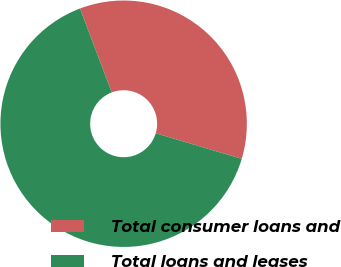Convert chart. <chart><loc_0><loc_0><loc_500><loc_500><pie_chart><fcel>Total consumer loans and<fcel>Total loans and leases<nl><fcel>35.36%<fcel>64.64%<nl></chart> 